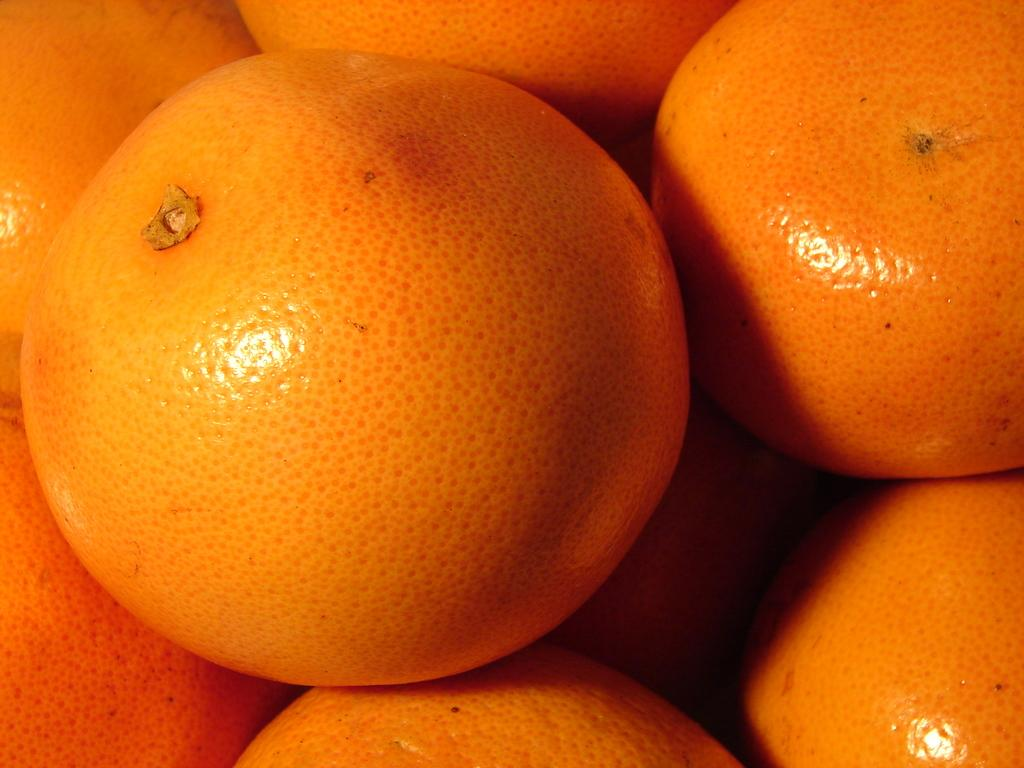What is the main subject in the center of the image? There are oranges in the center of the image. Can you describe the or estimate the number of oranges in the image? The number of oranges in the image cannot be definitively determined without a clear reference point or scale. What might be a possible use for the oranges in the image? The oranges in the image might be used for eating, juicing, or decoration. What type of doctor is examining the canvas in the image? There is no doctor or canvas present in the image; it features oranges in the center. 